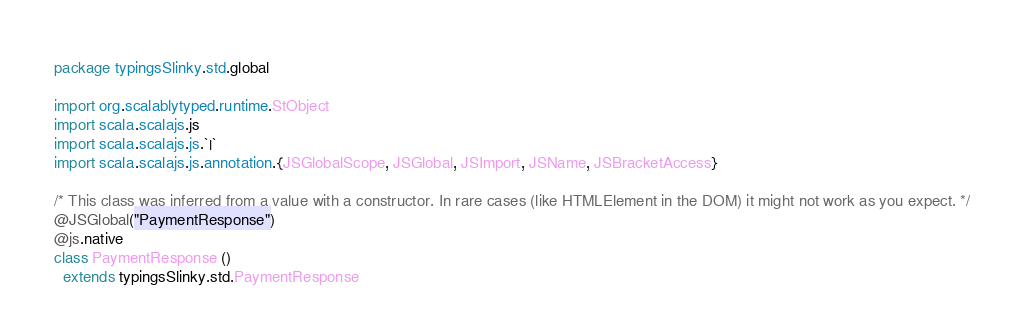Convert code to text. <code><loc_0><loc_0><loc_500><loc_500><_Scala_>package typingsSlinky.std.global

import org.scalablytyped.runtime.StObject
import scala.scalajs.js
import scala.scalajs.js.`|`
import scala.scalajs.js.annotation.{JSGlobalScope, JSGlobal, JSImport, JSName, JSBracketAccess}

/* This class was inferred from a value with a constructor. In rare cases (like HTMLElement in the DOM) it might not work as you expect. */
@JSGlobal("PaymentResponse")
@js.native
class PaymentResponse ()
  extends typingsSlinky.std.PaymentResponse
</code> 